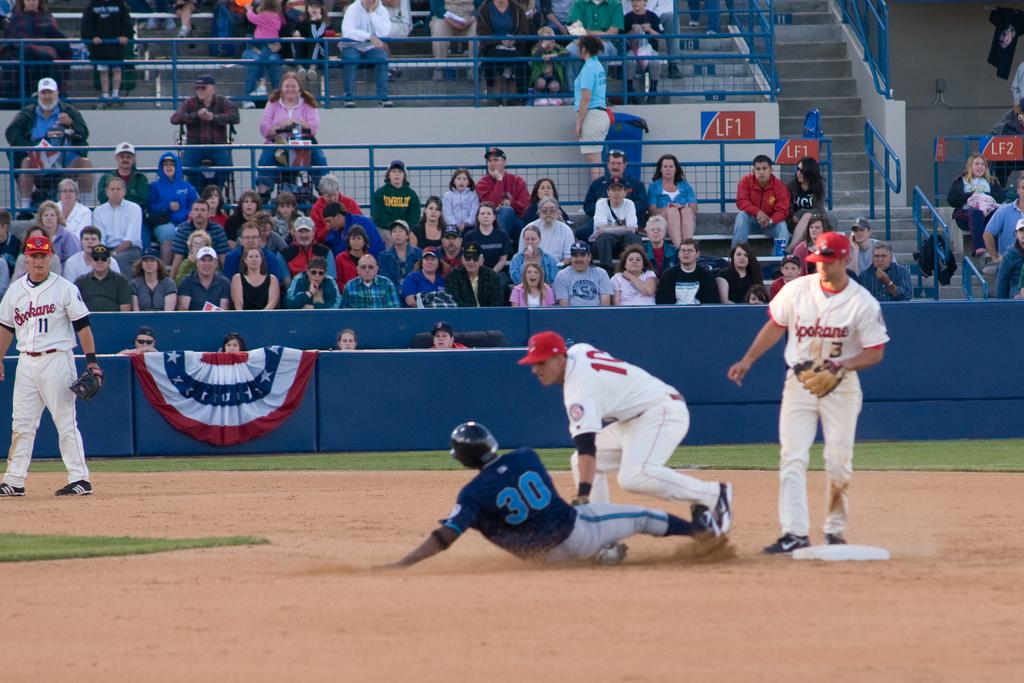What teams is playeing?
Your response must be concise. Unanswerable. What is the number of a player?
Give a very brief answer. 30. 